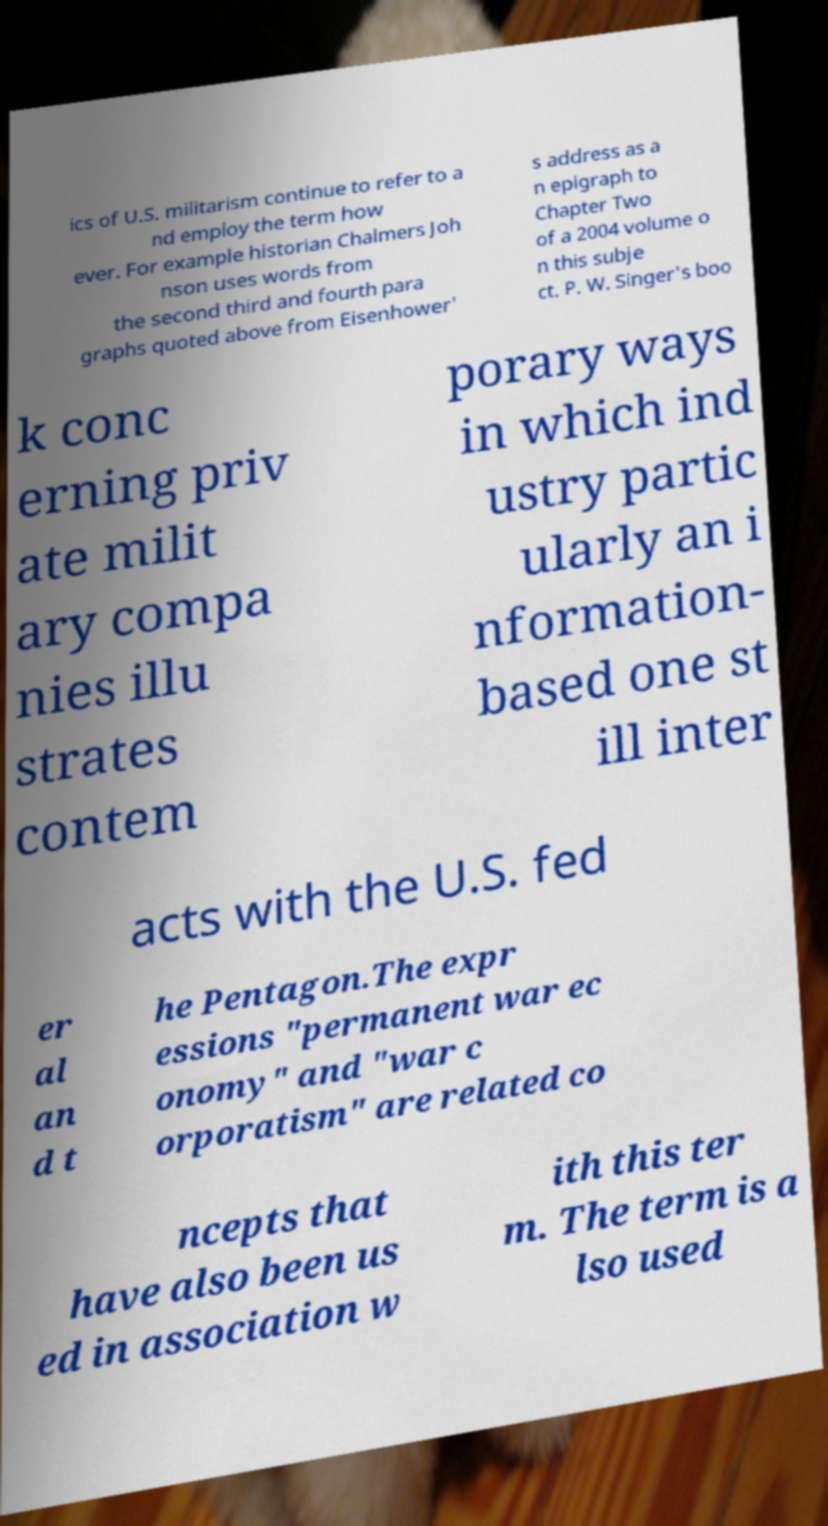I need the written content from this picture converted into text. Can you do that? ics of U.S. militarism continue to refer to a nd employ the term how ever. For example historian Chalmers Joh nson uses words from the second third and fourth para graphs quoted above from Eisenhower' s address as a n epigraph to Chapter Two of a 2004 volume o n this subje ct. P. W. Singer's boo k conc erning priv ate milit ary compa nies illu strates contem porary ways in which ind ustry partic ularly an i nformation- based one st ill inter acts with the U.S. fed er al an d t he Pentagon.The expr essions "permanent war ec onomy" and "war c orporatism" are related co ncepts that have also been us ed in association w ith this ter m. The term is a lso used 